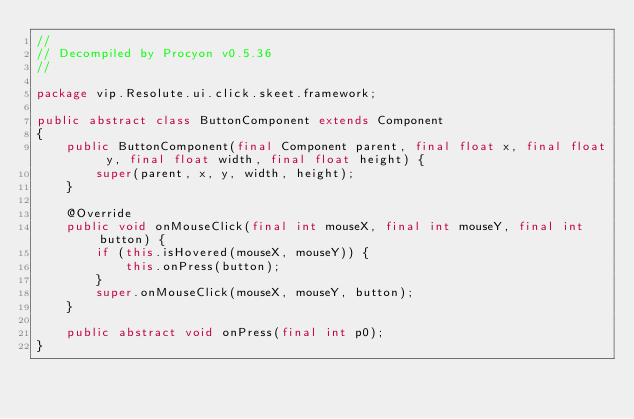<code> <loc_0><loc_0><loc_500><loc_500><_Java_>// 
// Decompiled by Procyon v0.5.36
// 

package vip.Resolute.ui.click.skeet.framework;

public abstract class ButtonComponent extends Component
{
    public ButtonComponent(final Component parent, final float x, final float y, final float width, final float height) {
        super(parent, x, y, width, height);
    }
    
    @Override
    public void onMouseClick(final int mouseX, final int mouseY, final int button) {
        if (this.isHovered(mouseX, mouseY)) {
            this.onPress(button);
        }
        super.onMouseClick(mouseX, mouseY, button);
    }
    
    public abstract void onPress(final int p0);
}
</code> 